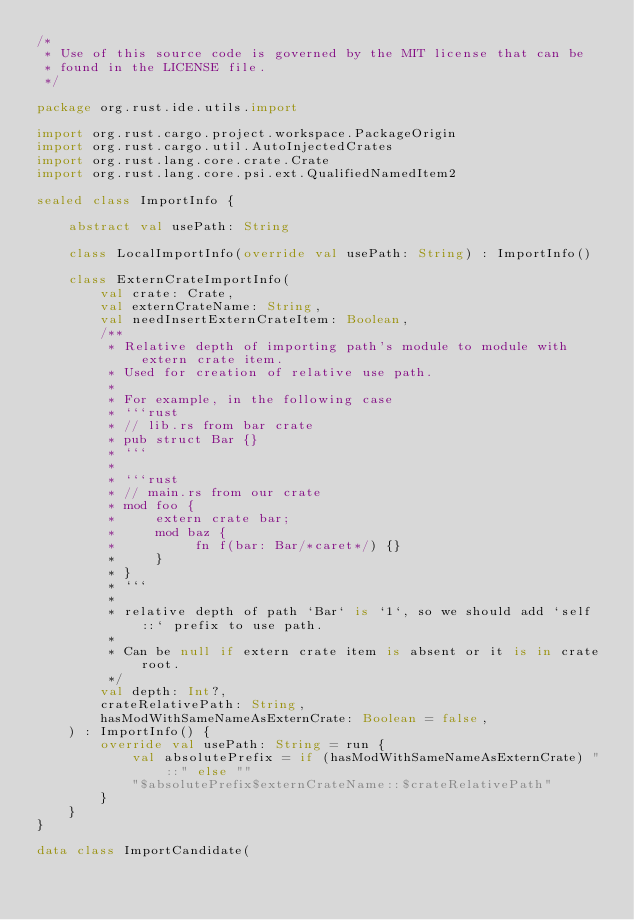Convert code to text. <code><loc_0><loc_0><loc_500><loc_500><_Kotlin_>/*
 * Use of this source code is governed by the MIT license that can be
 * found in the LICENSE file.
 */

package org.rust.ide.utils.import

import org.rust.cargo.project.workspace.PackageOrigin
import org.rust.cargo.util.AutoInjectedCrates
import org.rust.lang.core.crate.Crate
import org.rust.lang.core.psi.ext.QualifiedNamedItem2

sealed class ImportInfo {

    abstract val usePath: String

    class LocalImportInfo(override val usePath: String) : ImportInfo()

    class ExternCrateImportInfo(
        val crate: Crate,
        val externCrateName: String,
        val needInsertExternCrateItem: Boolean,
        /**
         * Relative depth of importing path's module to module with extern crate item.
         * Used for creation of relative use path.
         *
         * For example, in the following case
         * ```rust
         * // lib.rs from bar crate
         * pub struct Bar {}
         * ```
         *
         * ```rust
         * // main.rs from our crate
         * mod foo {
         *     extern crate bar;
         *     mod baz {
         *          fn f(bar: Bar/*caret*/) {}
         *     }
         * }
         * ```
         *
         * relative depth of path `Bar` is `1`, so we should add `self::` prefix to use path.
         *
         * Can be null if extern crate item is absent or it is in crate root.
         */
        val depth: Int?,
        crateRelativePath: String,
        hasModWithSameNameAsExternCrate: Boolean = false,
    ) : ImportInfo() {
        override val usePath: String = run {
            val absolutePrefix = if (hasModWithSameNameAsExternCrate) "::" else ""
            "$absolutePrefix$externCrateName::$crateRelativePath"
        }
    }
}

data class ImportCandidate(</code> 